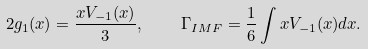<formula> <loc_0><loc_0><loc_500><loc_500>2 g _ { 1 } ( x ) = \frac { x V _ { - 1 } ( x ) } 3 , \quad \Gamma _ { I M F } = \frac { 1 } { 6 } \int x V _ { - 1 } ( x ) d x .</formula> 